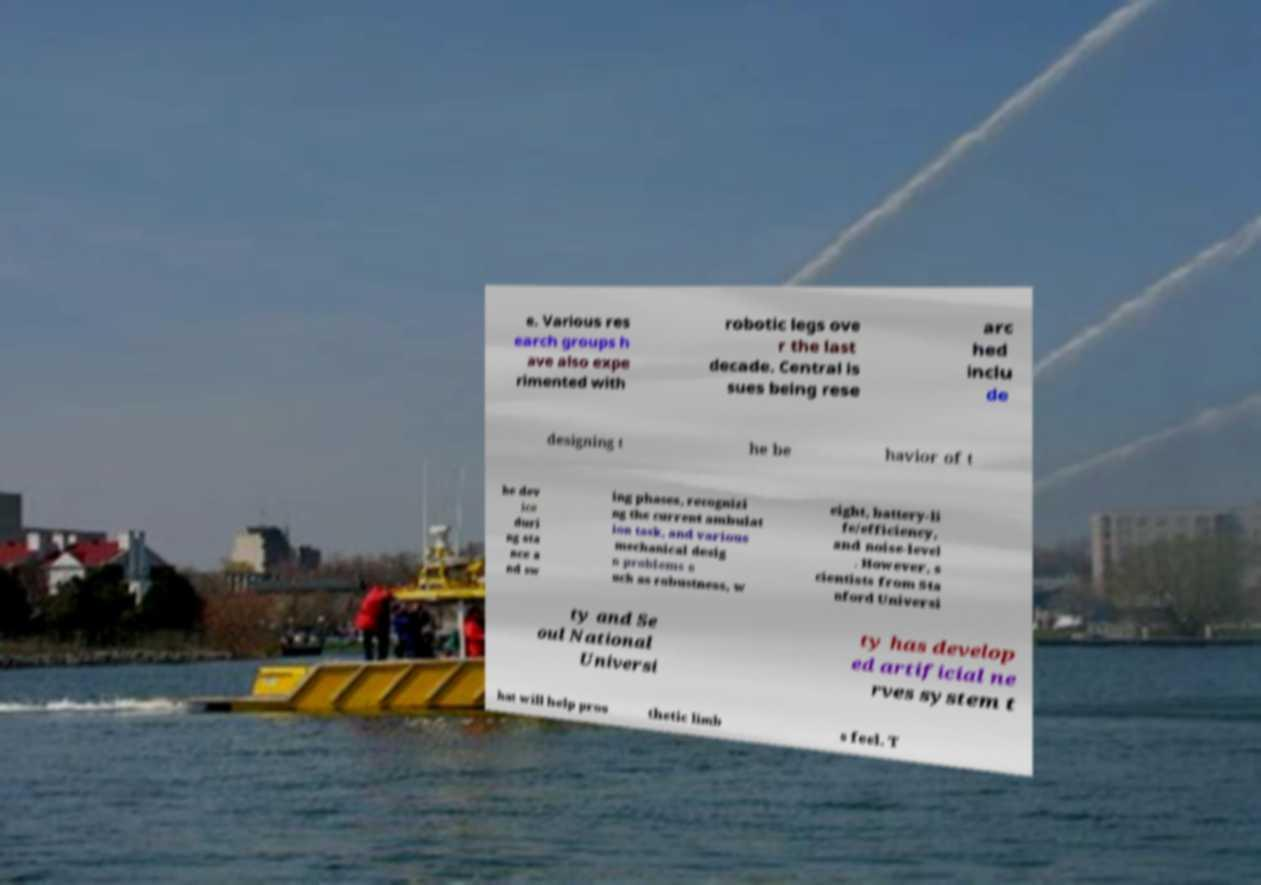For documentation purposes, I need the text within this image transcribed. Could you provide that? e. Various res earch groups h ave also expe rimented with robotic legs ove r the last decade. Central is sues being rese arc hed inclu de designing t he be havior of t he dev ice duri ng sta nce a nd sw ing phases, recognizi ng the current ambulat ion task, and various mechanical desig n problems s uch as robustness, w eight, battery-li fe/efficiency, and noise-level . However, s cientists from Sta nford Universi ty and Se oul National Universi ty has develop ed artificial ne rves system t hat will help pros thetic limb s feel. T 